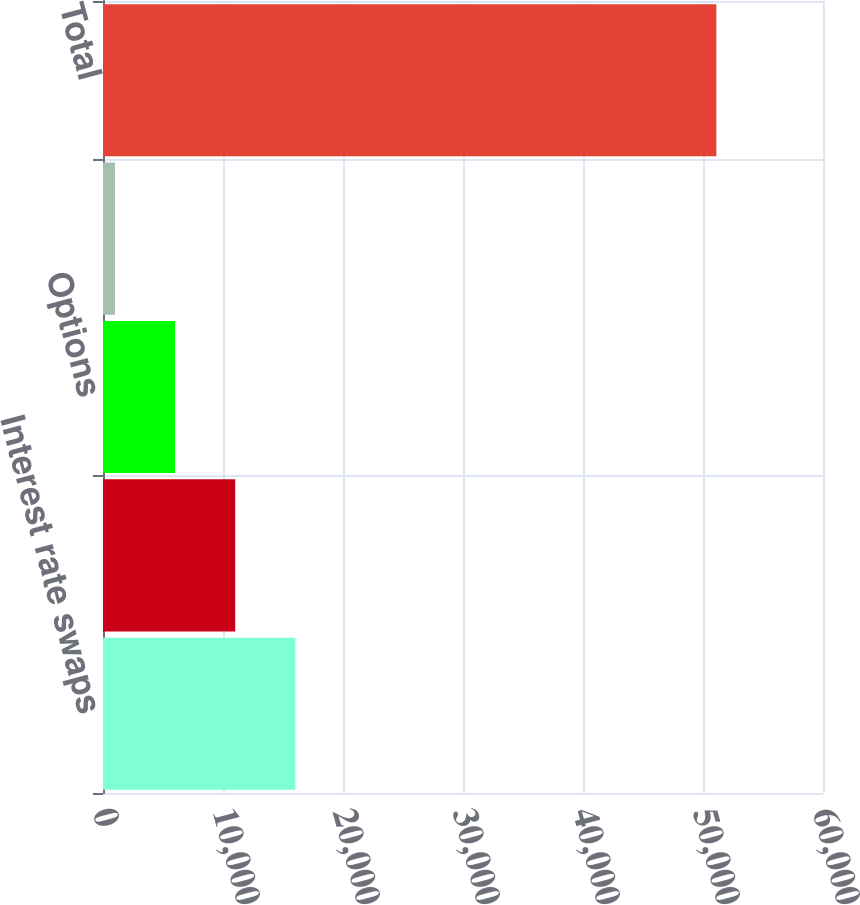Convert chart to OTSL. <chart><loc_0><loc_0><loc_500><loc_500><bar_chart><fcel>Interest rate swaps<fcel>Foreign currency swaps<fcel>Options<fcel>Financialforwards<fcel>Total<nl><fcel>16030.4<fcel>11018.6<fcel>6006.8<fcel>995<fcel>51113<nl></chart> 